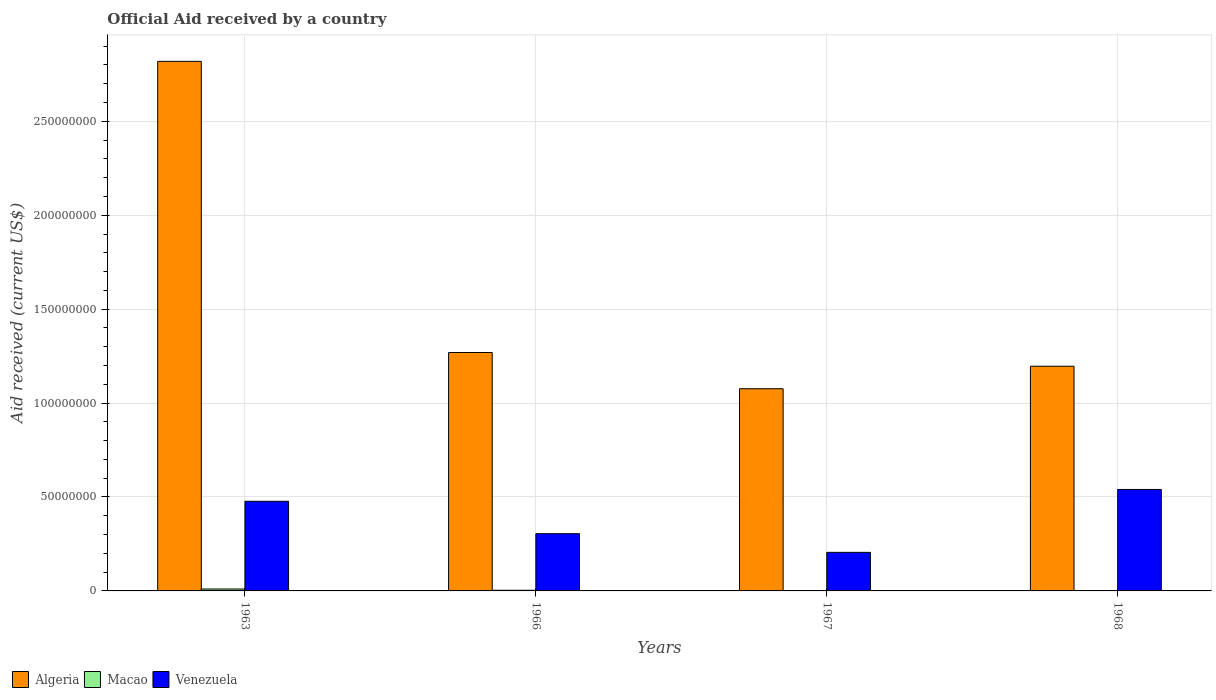How many groups of bars are there?
Keep it short and to the point. 4. How many bars are there on the 1st tick from the left?
Your answer should be very brief. 3. How many bars are there on the 3rd tick from the right?
Provide a succinct answer. 3. What is the net official aid received in Algeria in 1968?
Provide a succinct answer. 1.20e+08. Across all years, what is the maximum net official aid received in Venezuela?
Your response must be concise. 5.40e+07. In which year was the net official aid received in Algeria maximum?
Give a very brief answer. 1963. In which year was the net official aid received in Macao minimum?
Your response must be concise. 1967. What is the total net official aid received in Macao in the graph?
Offer a very short reply. 1.67e+06. What is the difference between the net official aid received in Venezuela in 1963 and that in 1967?
Ensure brevity in your answer.  2.72e+07. What is the difference between the net official aid received in Macao in 1966 and the net official aid received in Algeria in 1963?
Give a very brief answer. -2.82e+08. What is the average net official aid received in Macao per year?
Your answer should be very brief. 4.18e+05. In the year 1966, what is the difference between the net official aid received in Venezuela and net official aid received in Macao?
Your answer should be very brief. 3.01e+07. In how many years, is the net official aid received in Algeria greater than 220000000 US$?
Make the answer very short. 1. What is the ratio of the net official aid received in Macao in 1966 to that in 1967?
Provide a short and direct response. 2.43. What is the difference between the highest and the second highest net official aid received in Venezuela?
Your answer should be very brief. 6.29e+06. What is the difference between the highest and the lowest net official aid received in Macao?
Offer a very short reply. 8.80e+05. In how many years, is the net official aid received in Venezuela greater than the average net official aid received in Venezuela taken over all years?
Offer a terse response. 2. Is the sum of the net official aid received in Venezuela in 1963 and 1966 greater than the maximum net official aid received in Macao across all years?
Your response must be concise. Yes. What does the 3rd bar from the left in 1966 represents?
Offer a very short reply. Venezuela. What does the 3rd bar from the right in 1968 represents?
Provide a succinct answer. Algeria. Is it the case that in every year, the sum of the net official aid received in Algeria and net official aid received in Venezuela is greater than the net official aid received in Macao?
Your answer should be very brief. Yes. Where does the legend appear in the graph?
Your response must be concise. Bottom left. How many legend labels are there?
Provide a short and direct response. 3. What is the title of the graph?
Offer a very short reply. Official Aid received by a country. Does "France" appear as one of the legend labels in the graph?
Your answer should be very brief. No. What is the label or title of the X-axis?
Your response must be concise. Years. What is the label or title of the Y-axis?
Your response must be concise. Aid received (current US$). What is the Aid received (current US$) in Algeria in 1963?
Ensure brevity in your answer.  2.82e+08. What is the Aid received (current US$) of Macao in 1963?
Ensure brevity in your answer.  1.02e+06. What is the Aid received (current US$) of Venezuela in 1963?
Your response must be concise. 4.77e+07. What is the Aid received (current US$) of Algeria in 1966?
Provide a short and direct response. 1.27e+08. What is the Aid received (current US$) of Venezuela in 1966?
Ensure brevity in your answer.  3.05e+07. What is the Aid received (current US$) in Algeria in 1967?
Offer a terse response. 1.08e+08. What is the Aid received (current US$) in Venezuela in 1967?
Offer a very short reply. 2.05e+07. What is the Aid received (current US$) of Algeria in 1968?
Keep it short and to the point. 1.20e+08. What is the Aid received (current US$) of Macao in 1968?
Make the answer very short. 1.70e+05. What is the Aid received (current US$) of Venezuela in 1968?
Offer a terse response. 5.40e+07. Across all years, what is the maximum Aid received (current US$) in Algeria?
Your answer should be compact. 2.82e+08. Across all years, what is the maximum Aid received (current US$) of Macao?
Your answer should be very brief. 1.02e+06. Across all years, what is the maximum Aid received (current US$) in Venezuela?
Provide a succinct answer. 5.40e+07. Across all years, what is the minimum Aid received (current US$) of Algeria?
Your answer should be very brief. 1.08e+08. Across all years, what is the minimum Aid received (current US$) in Macao?
Provide a succinct answer. 1.40e+05. Across all years, what is the minimum Aid received (current US$) in Venezuela?
Give a very brief answer. 2.05e+07. What is the total Aid received (current US$) in Algeria in the graph?
Give a very brief answer. 6.36e+08. What is the total Aid received (current US$) in Macao in the graph?
Make the answer very short. 1.67e+06. What is the total Aid received (current US$) of Venezuela in the graph?
Keep it short and to the point. 1.53e+08. What is the difference between the Aid received (current US$) in Algeria in 1963 and that in 1966?
Give a very brief answer. 1.55e+08. What is the difference between the Aid received (current US$) in Macao in 1963 and that in 1966?
Make the answer very short. 6.80e+05. What is the difference between the Aid received (current US$) in Venezuela in 1963 and that in 1966?
Your answer should be very brief. 1.72e+07. What is the difference between the Aid received (current US$) of Algeria in 1963 and that in 1967?
Your answer should be very brief. 1.74e+08. What is the difference between the Aid received (current US$) of Macao in 1963 and that in 1967?
Your answer should be very brief. 8.80e+05. What is the difference between the Aid received (current US$) of Venezuela in 1963 and that in 1967?
Make the answer very short. 2.72e+07. What is the difference between the Aid received (current US$) of Algeria in 1963 and that in 1968?
Offer a terse response. 1.62e+08. What is the difference between the Aid received (current US$) in Macao in 1963 and that in 1968?
Provide a short and direct response. 8.50e+05. What is the difference between the Aid received (current US$) in Venezuela in 1963 and that in 1968?
Your answer should be compact. -6.29e+06. What is the difference between the Aid received (current US$) in Algeria in 1966 and that in 1967?
Keep it short and to the point. 1.93e+07. What is the difference between the Aid received (current US$) of Venezuela in 1966 and that in 1967?
Your answer should be very brief. 9.94e+06. What is the difference between the Aid received (current US$) of Algeria in 1966 and that in 1968?
Offer a terse response. 7.31e+06. What is the difference between the Aid received (current US$) of Macao in 1966 and that in 1968?
Your answer should be very brief. 1.70e+05. What is the difference between the Aid received (current US$) in Venezuela in 1966 and that in 1968?
Provide a succinct answer. -2.35e+07. What is the difference between the Aid received (current US$) in Algeria in 1967 and that in 1968?
Offer a very short reply. -1.20e+07. What is the difference between the Aid received (current US$) in Macao in 1967 and that in 1968?
Provide a succinct answer. -3.00e+04. What is the difference between the Aid received (current US$) in Venezuela in 1967 and that in 1968?
Provide a succinct answer. -3.35e+07. What is the difference between the Aid received (current US$) of Algeria in 1963 and the Aid received (current US$) of Macao in 1966?
Offer a very short reply. 2.82e+08. What is the difference between the Aid received (current US$) of Algeria in 1963 and the Aid received (current US$) of Venezuela in 1966?
Provide a succinct answer. 2.51e+08. What is the difference between the Aid received (current US$) in Macao in 1963 and the Aid received (current US$) in Venezuela in 1966?
Keep it short and to the point. -2.94e+07. What is the difference between the Aid received (current US$) of Algeria in 1963 and the Aid received (current US$) of Macao in 1967?
Keep it short and to the point. 2.82e+08. What is the difference between the Aid received (current US$) of Algeria in 1963 and the Aid received (current US$) of Venezuela in 1967?
Your response must be concise. 2.61e+08. What is the difference between the Aid received (current US$) in Macao in 1963 and the Aid received (current US$) in Venezuela in 1967?
Make the answer very short. -1.95e+07. What is the difference between the Aid received (current US$) in Algeria in 1963 and the Aid received (current US$) in Macao in 1968?
Provide a short and direct response. 2.82e+08. What is the difference between the Aid received (current US$) of Algeria in 1963 and the Aid received (current US$) of Venezuela in 1968?
Provide a short and direct response. 2.28e+08. What is the difference between the Aid received (current US$) of Macao in 1963 and the Aid received (current US$) of Venezuela in 1968?
Offer a terse response. -5.30e+07. What is the difference between the Aid received (current US$) of Algeria in 1966 and the Aid received (current US$) of Macao in 1967?
Your answer should be very brief. 1.27e+08. What is the difference between the Aid received (current US$) of Algeria in 1966 and the Aid received (current US$) of Venezuela in 1967?
Offer a very short reply. 1.06e+08. What is the difference between the Aid received (current US$) in Macao in 1966 and the Aid received (current US$) in Venezuela in 1967?
Your response must be concise. -2.02e+07. What is the difference between the Aid received (current US$) of Algeria in 1966 and the Aid received (current US$) of Macao in 1968?
Keep it short and to the point. 1.27e+08. What is the difference between the Aid received (current US$) of Algeria in 1966 and the Aid received (current US$) of Venezuela in 1968?
Provide a short and direct response. 7.29e+07. What is the difference between the Aid received (current US$) of Macao in 1966 and the Aid received (current US$) of Venezuela in 1968?
Your response must be concise. -5.37e+07. What is the difference between the Aid received (current US$) of Algeria in 1967 and the Aid received (current US$) of Macao in 1968?
Give a very brief answer. 1.07e+08. What is the difference between the Aid received (current US$) in Algeria in 1967 and the Aid received (current US$) in Venezuela in 1968?
Provide a succinct answer. 5.36e+07. What is the difference between the Aid received (current US$) of Macao in 1967 and the Aid received (current US$) of Venezuela in 1968?
Your response must be concise. -5.39e+07. What is the average Aid received (current US$) in Algeria per year?
Your answer should be compact. 1.59e+08. What is the average Aid received (current US$) in Macao per year?
Keep it short and to the point. 4.18e+05. What is the average Aid received (current US$) of Venezuela per year?
Give a very brief answer. 3.82e+07. In the year 1963, what is the difference between the Aid received (current US$) of Algeria and Aid received (current US$) of Macao?
Your answer should be very brief. 2.81e+08. In the year 1963, what is the difference between the Aid received (current US$) in Algeria and Aid received (current US$) in Venezuela?
Your response must be concise. 2.34e+08. In the year 1963, what is the difference between the Aid received (current US$) of Macao and Aid received (current US$) of Venezuela?
Offer a very short reply. -4.67e+07. In the year 1966, what is the difference between the Aid received (current US$) of Algeria and Aid received (current US$) of Macao?
Your response must be concise. 1.27e+08. In the year 1966, what is the difference between the Aid received (current US$) of Algeria and Aid received (current US$) of Venezuela?
Your response must be concise. 9.64e+07. In the year 1966, what is the difference between the Aid received (current US$) in Macao and Aid received (current US$) in Venezuela?
Provide a short and direct response. -3.01e+07. In the year 1967, what is the difference between the Aid received (current US$) of Algeria and Aid received (current US$) of Macao?
Your answer should be very brief. 1.08e+08. In the year 1967, what is the difference between the Aid received (current US$) of Algeria and Aid received (current US$) of Venezuela?
Your answer should be compact. 8.71e+07. In the year 1967, what is the difference between the Aid received (current US$) in Macao and Aid received (current US$) in Venezuela?
Your answer should be very brief. -2.04e+07. In the year 1968, what is the difference between the Aid received (current US$) in Algeria and Aid received (current US$) in Macao?
Provide a short and direct response. 1.19e+08. In the year 1968, what is the difference between the Aid received (current US$) of Algeria and Aid received (current US$) of Venezuela?
Provide a succinct answer. 6.56e+07. In the year 1968, what is the difference between the Aid received (current US$) of Macao and Aid received (current US$) of Venezuela?
Your response must be concise. -5.38e+07. What is the ratio of the Aid received (current US$) of Algeria in 1963 to that in 1966?
Make the answer very short. 2.22. What is the ratio of the Aid received (current US$) of Macao in 1963 to that in 1966?
Offer a terse response. 3. What is the ratio of the Aid received (current US$) of Venezuela in 1963 to that in 1966?
Provide a succinct answer. 1.57. What is the ratio of the Aid received (current US$) in Algeria in 1963 to that in 1967?
Provide a succinct answer. 2.62. What is the ratio of the Aid received (current US$) in Macao in 1963 to that in 1967?
Offer a very short reply. 7.29. What is the ratio of the Aid received (current US$) of Venezuela in 1963 to that in 1967?
Offer a very short reply. 2.32. What is the ratio of the Aid received (current US$) in Algeria in 1963 to that in 1968?
Your answer should be very brief. 2.36. What is the ratio of the Aid received (current US$) of Venezuela in 1963 to that in 1968?
Offer a terse response. 0.88. What is the ratio of the Aid received (current US$) of Algeria in 1966 to that in 1967?
Offer a terse response. 1.18. What is the ratio of the Aid received (current US$) of Macao in 1966 to that in 1967?
Give a very brief answer. 2.43. What is the ratio of the Aid received (current US$) in Venezuela in 1966 to that in 1967?
Provide a succinct answer. 1.48. What is the ratio of the Aid received (current US$) in Algeria in 1966 to that in 1968?
Make the answer very short. 1.06. What is the ratio of the Aid received (current US$) of Venezuela in 1966 to that in 1968?
Your answer should be compact. 0.56. What is the ratio of the Aid received (current US$) of Algeria in 1967 to that in 1968?
Ensure brevity in your answer.  0.9. What is the ratio of the Aid received (current US$) of Macao in 1967 to that in 1968?
Give a very brief answer. 0.82. What is the ratio of the Aid received (current US$) of Venezuela in 1967 to that in 1968?
Give a very brief answer. 0.38. What is the difference between the highest and the second highest Aid received (current US$) in Algeria?
Give a very brief answer. 1.55e+08. What is the difference between the highest and the second highest Aid received (current US$) of Macao?
Provide a succinct answer. 6.80e+05. What is the difference between the highest and the second highest Aid received (current US$) in Venezuela?
Ensure brevity in your answer.  6.29e+06. What is the difference between the highest and the lowest Aid received (current US$) in Algeria?
Keep it short and to the point. 1.74e+08. What is the difference between the highest and the lowest Aid received (current US$) of Macao?
Keep it short and to the point. 8.80e+05. What is the difference between the highest and the lowest Aid received (current US$) in Venezuela?
Offer a very short reply. 3.35e+07. 